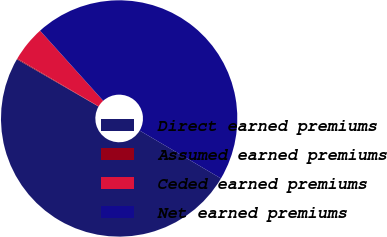<chart> <loc_0><loc_0><loc_500><loc_500><pie_chart><fcel>Direct earned premiums<fcel>Assumed earned premiums<fcel>Ceded earned premiums<fcel>Net earned premiums<nl><fcel>49.88%<fcel>0.12%<fcel>4.86%<fcel>45.14%<nl></chart> 